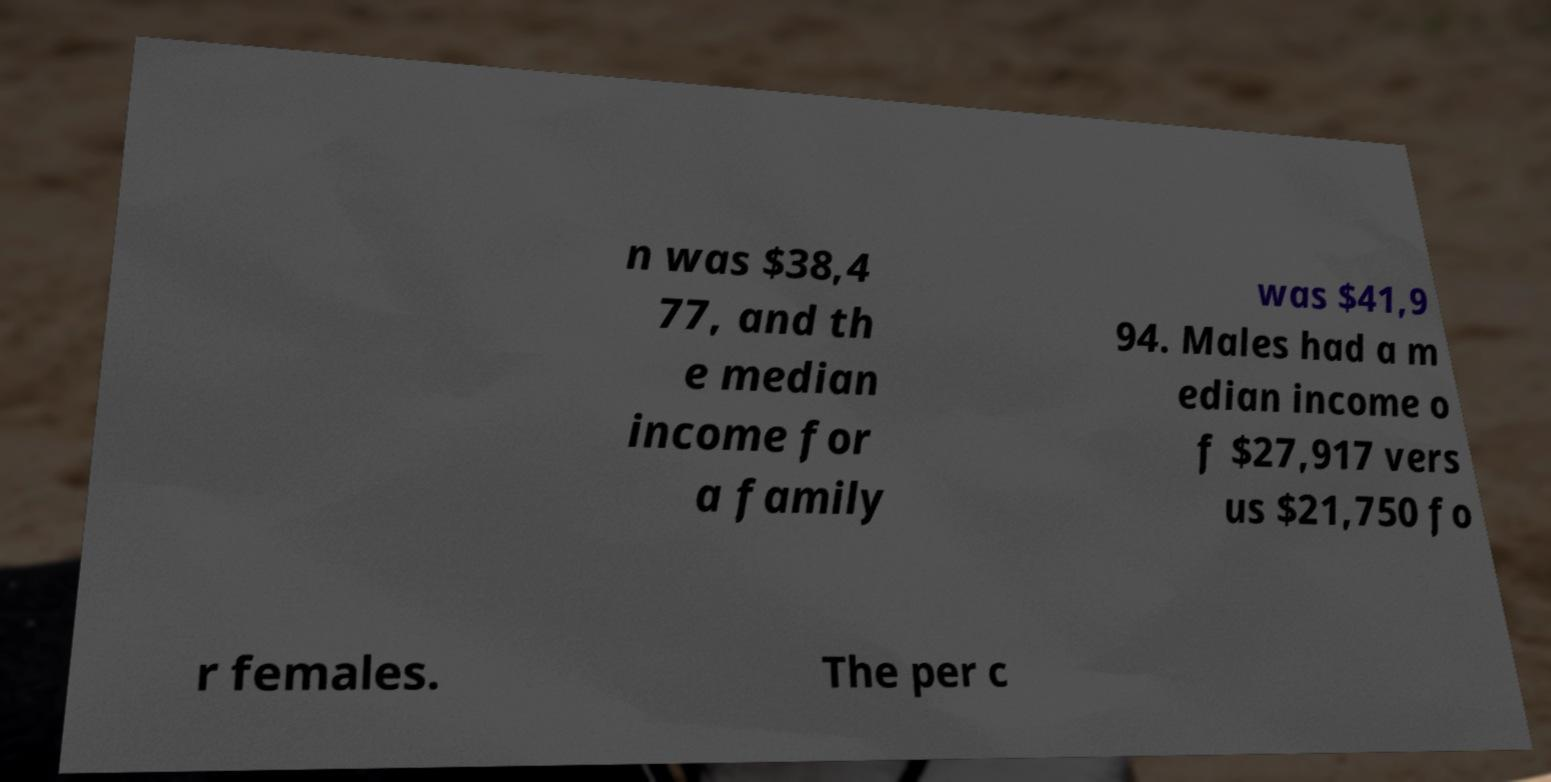Can you accurately transcribe the text from the provided image for me? n was $38,4 77, and th e median income for a family was $41,9 94. Males had a m edian income o f $27,917 vers us $21,750 fo r females. The per c 